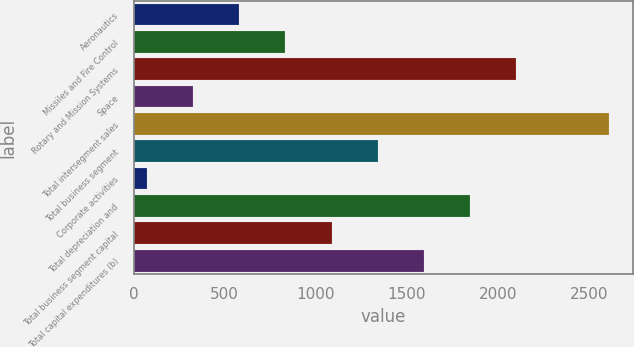<chart> <loc_0><loc_0><loc_500><loc_500><bar_chart><fcel>Aeronautics<fcel>Missiles and Fire Control<fcel>Rotary and Mission Systems<fcel>Space<fcel>Total intersegment sales<fcel>Total business segment<fcel>Corporate activities<fcel>Total depreciation and<fcel>Total business segment capital<fcel>Total capital expenditures (b)<nl><fcel>579.2<fcel>832.8<fcel>2100.8<fcel>325.6<fcel>2608<fcel>1340<fcel>72<fcel>1847.2<fcel>1086.4<fcel>1593.6<nl></chart> 